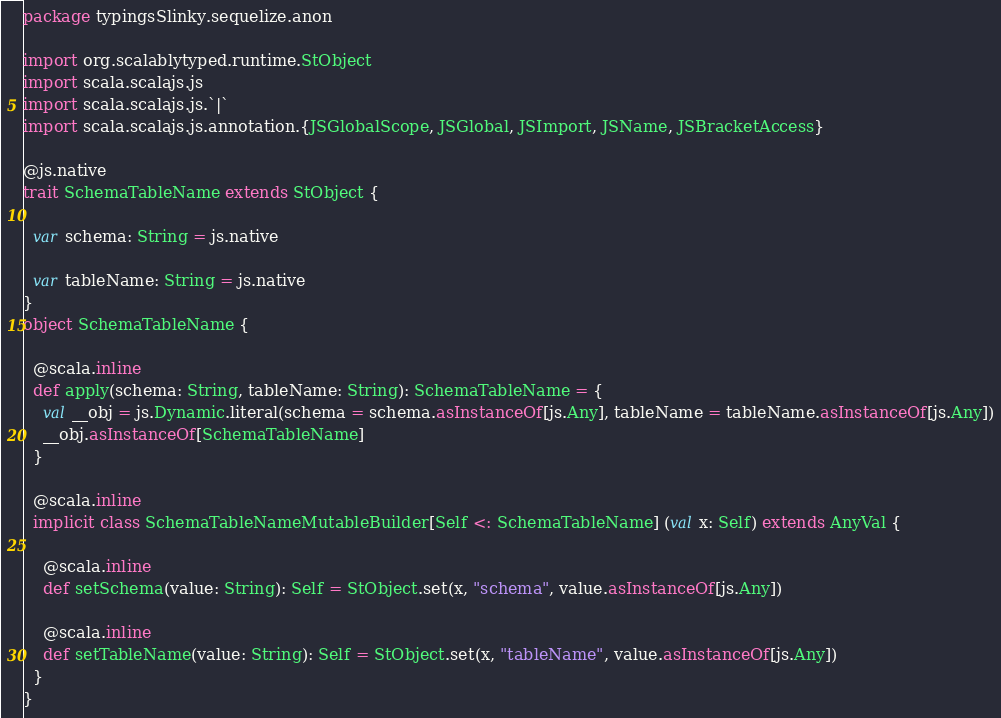<code> <loc_0><loc_0><loc_500><loc_500><_Scala_>package typingsSlinky.sequelize.anon

import org.scalablytyped.runtime.StObject
import scala.scalajs.js
import scala.scalajs.js.`|`
import scala.scalajs.js.annotation.{JSGlobalScope, JSGlobal, JSImport, JSName, JSBracketAccess}

@js.native
trait SchemaTableName extends StObject {
  
  var schema: String = js.native
  
  var tableName: String = js.native
}
object SchemaTableName {
  
  @scala.inline
  def apply(schema: String, tableName: String): SchemaTableName = {
    val __obj = js.Dynamic.literal(schema = schema.asInstanceOf[js.Any], tableName = tableName.asInstanceOf[js.Any])
    __obj.asInstanceOf[SchemaTableName]
  }
  
  @scala.inline
  implicit class SchemaTableNameMutableBuilder[Self <: SchemaTableName] (val x: Self) extends AnyVal {
    
    @scala.inline
    def setSchema(value: String): Self = StObject.set(x, "schema", value.asInstanceOf[js.Any])
    
    @scala.inline
    def setTableName(value: String): Self = StObject.set(x, "tableName", value.asInstanceOf[js.Any])
  }
}
</code> 